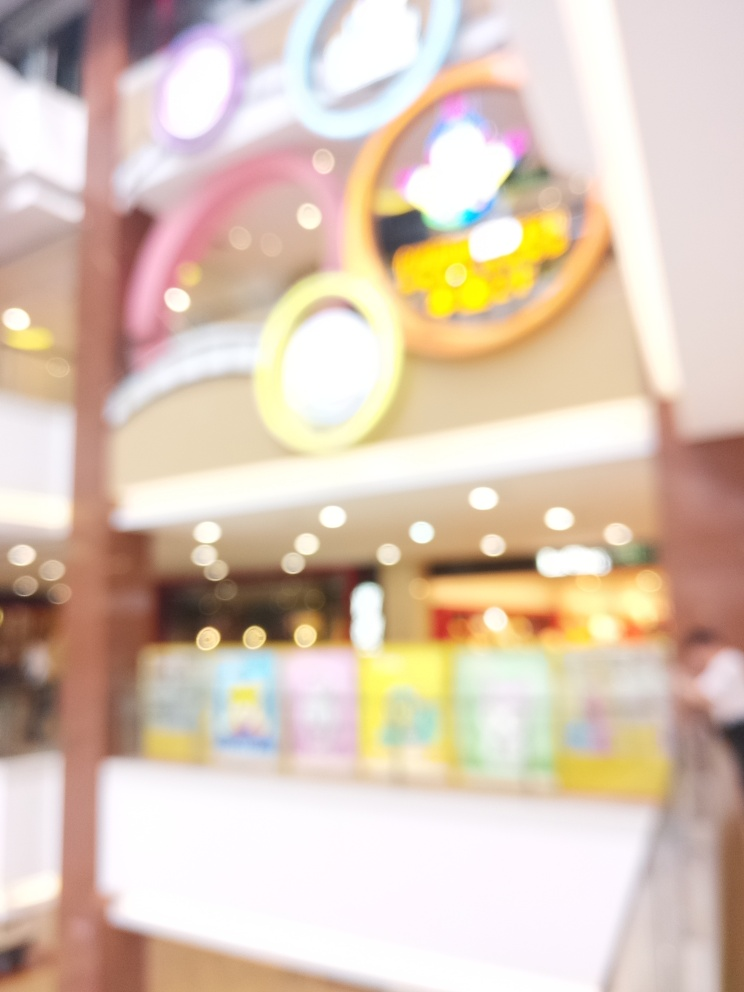What might be the artistic or practical purpose behind presenting an image with such high blurriness? The use of high blurriness in this image could serve multiple purposes. Artistically, it might be employed to convey a sense of movement or evoke emotions such as confusion or mystery. Practically, it might be used to focus viewers' attention away from specifics, pushing them to contemplate the overall atmosphere or theme of the setting. 